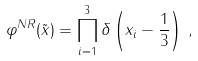Convert formula to latex. <formula><loc_0><loc_0><loc_500><loc_500>\varphi ^ { N R } ( \tilde { x } ) = \prod _ { i = 1 } ^ { 3 } \delta \left ( x _ { i } - \frac { 1 } { 3 } \right ) \, ,</formula> 